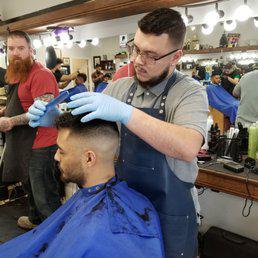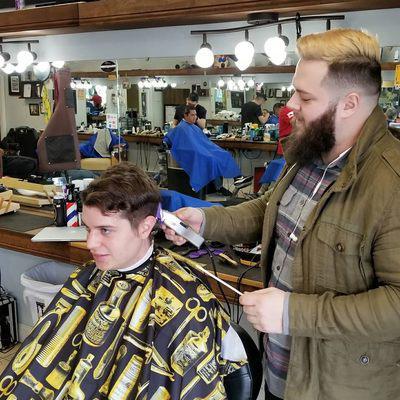The first image is the image on the left, the second image is the image on the right. Examine the images to the left and right. Is the description "Each image shows a barber in the foreground working on the hair of a customer wearing a smock, and only one of the images shows a customer in a blue smock." accurate? Answer yes or no. Yes. The first image is the image on the left, the second image is the image on the right. For the images displayed, is the sentence "The left and right image contains the same number of barbers shaving and combing men with dark hair." factually correct? Answer yes or no. Yes. 